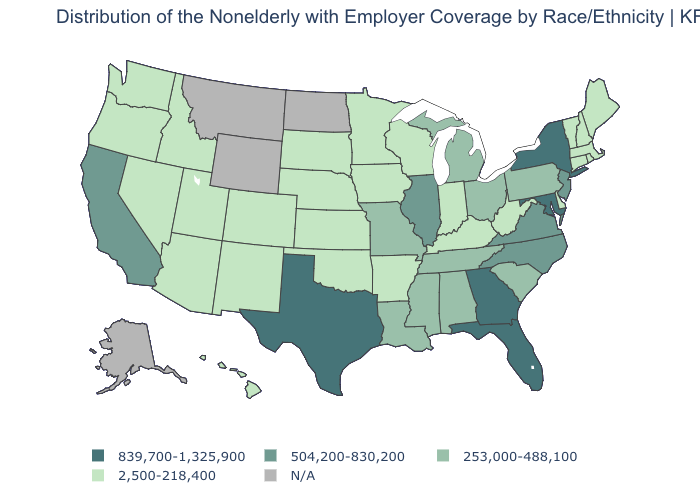What is the value of Kansas?
Answer briefly. 2,500-218,400. Is the legend a continuous bar?
Quick response, please. No. What is the value of Oregon?
Concise answer only. 2,500-218,400. Name the states that have a value in the range 839,700-1,325,900?
Quick response, please. Florida, Georgia, Maryland, New York, Texas. What is the value of Oregon?
Be succinct. 2,500-218,400. What is the value of Virginia?
Write a very short answer. 504,200-830,200. What is the highest value in the USA?
Concise answer only. 839,700-1,325,900. Which states have the lowest value in the Northeast?
Quick response, please. Connecticut, Maine, Massachusetts, New Hampshire, Rhode Island, Vermont. Among the states that border Connecticut , which have the lowest value?
Answer briefly. Massachusetts, Rhode Island. What is the value of Nebraska?
Answer briefly. 2,500-218,400. Name the states that have a value in the range 504,200-830,200?
Be succinct. California, Illinois, New Jersey, North Carolina, Virginia. Among the states that border Virginia , which have the highest value?
Be succinct. Maryland. What is the lowest value in the USA?
Keep it brief. 2,500-218,400. What is the value of Colorado?
Be succinct. 2,500-218,400. What is the value of Michigan?
Write a very short answer. 253,000-488,100. 